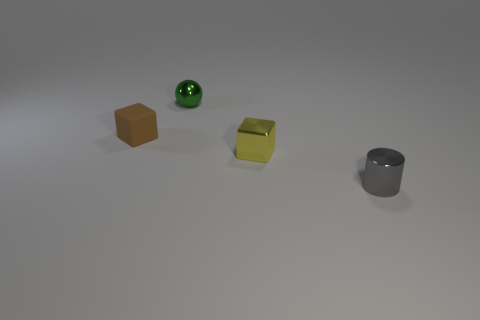Add 2 brown blocks. How many objects exist? 6 Subtract 2 cubes. How many cubes are left? 0 Subtract all blue balls. Subtract all blue cylinders. How many balls are left? 1 Subtract all green cylinders. How many blue cubes are left? 0 Subtract all green spheres. Subtract all brown cubes. How many objects are left? 2 Add 4 shiny cylinders. How many shiny cylinders are left? 5 Add 1 large gray rubber balls. How many large gray rubber balls exist? 1 Subtract 0 purple cylinders. How many objects are left? 4 